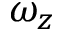Convert formula to latex. <formula><loc_0><loc_0><loc_500><loc_500>\omega _ { z }</formula> 